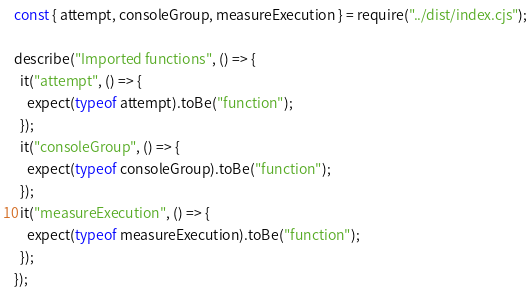<code> <loc_0><loc_0><loc_500><loc_500><_JavaScript_>const { attempt, consoleGroup, measureExecution } = require("../dist/index.cjs");

describe("Imported functions", () => {
  it("attempt", () => {
    expect(typeof attempt).toBe("function");
  });
  it("consoleGroup", () => {
    expect(typeof consoleGroup).toBe("function");
  });
  it("measureExecution", () => {
    expect(typeof measureExecution).toBe("function");
  });
});
</code> 